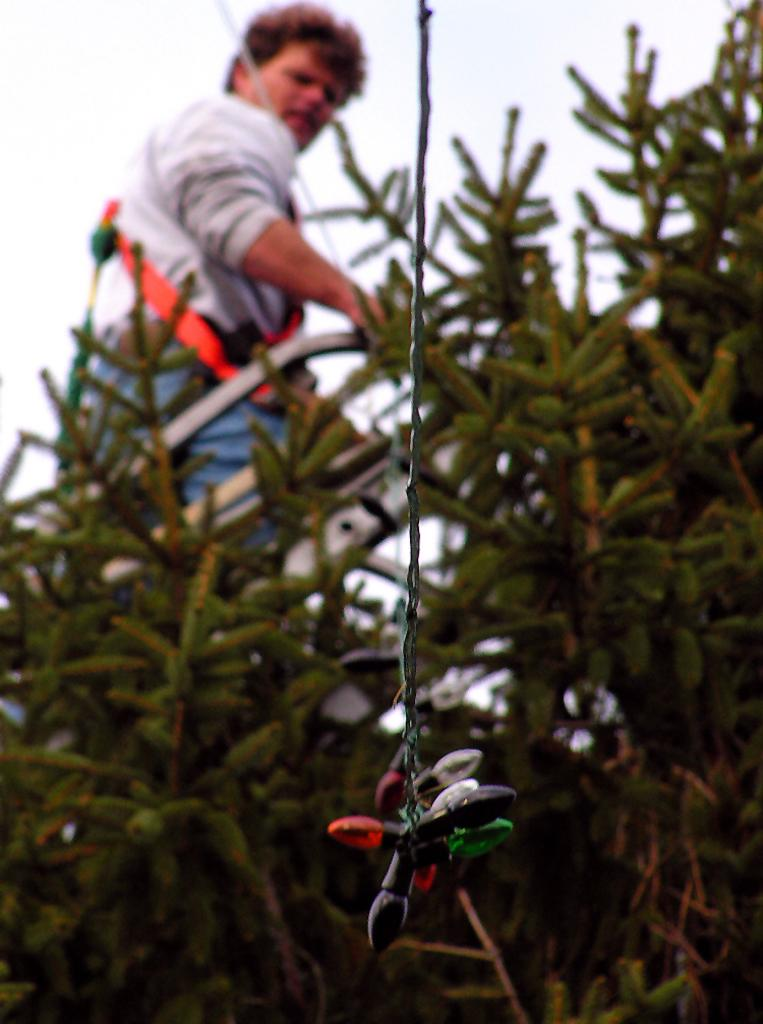What type of lighting is present in the image? There are decorative lights in the image. Can you describe the background of the image? There is a person and plants in the background of the image. What type of powder is being used by the person in the image? There is no indication of any powder being used in the image; the person is simply present in the background. 